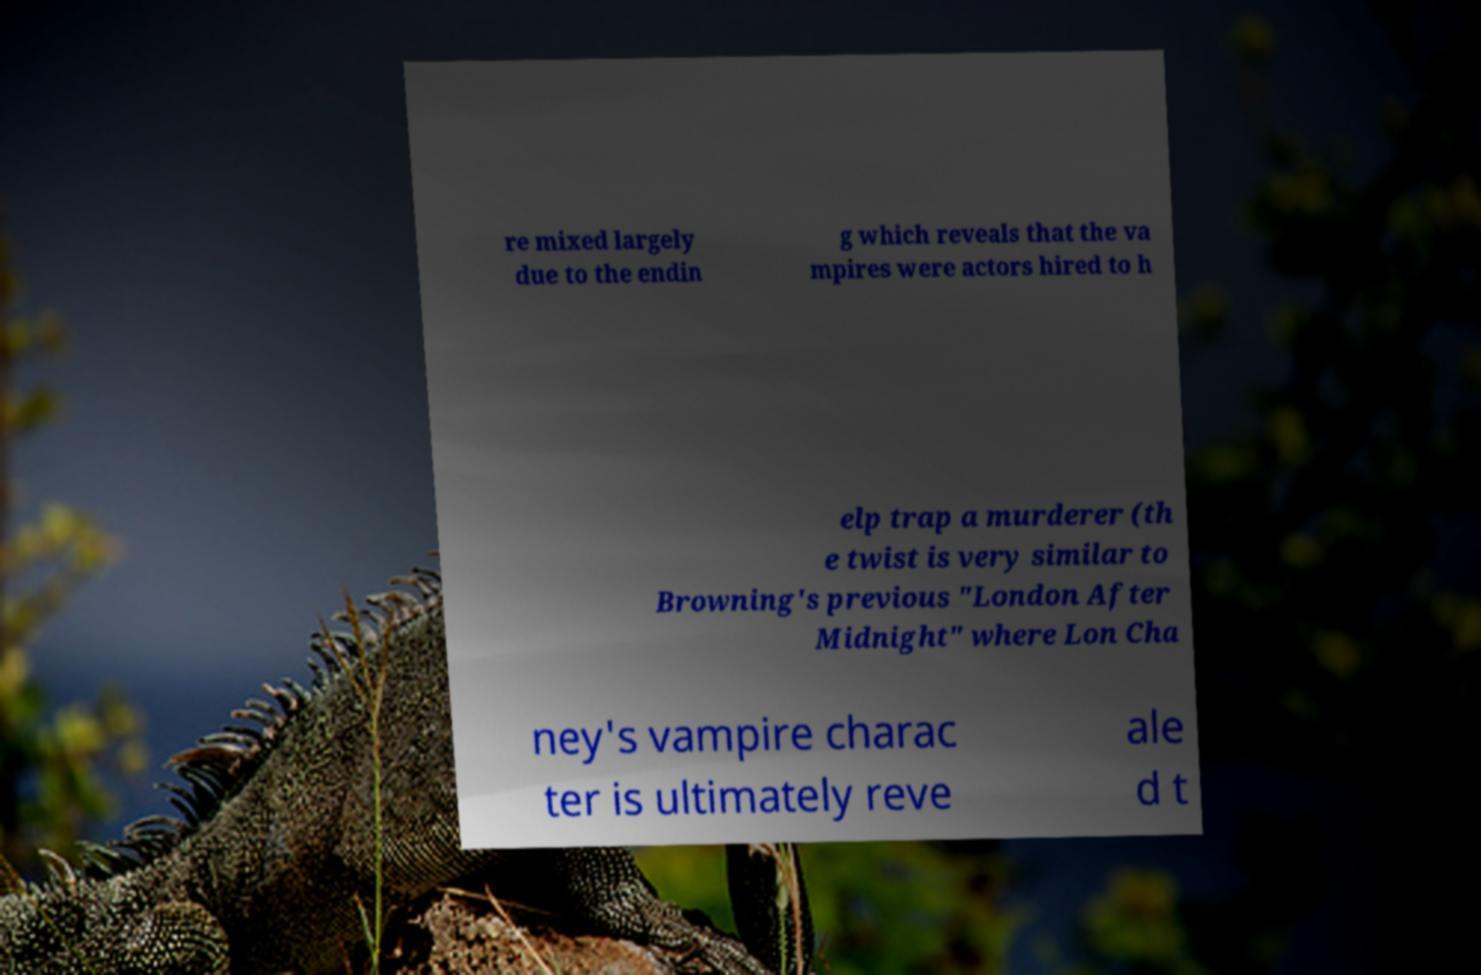I need the written content from this picture converted into text. Can you do that? re mixed largely due to the endin g which reveals that the va mpires were actors hired to h elp trap a murderer (th e twist is very similar to Browning's previous "London After Midnight" where Lon Cha ney's vampire charac ter is ultimately reve ale d t 